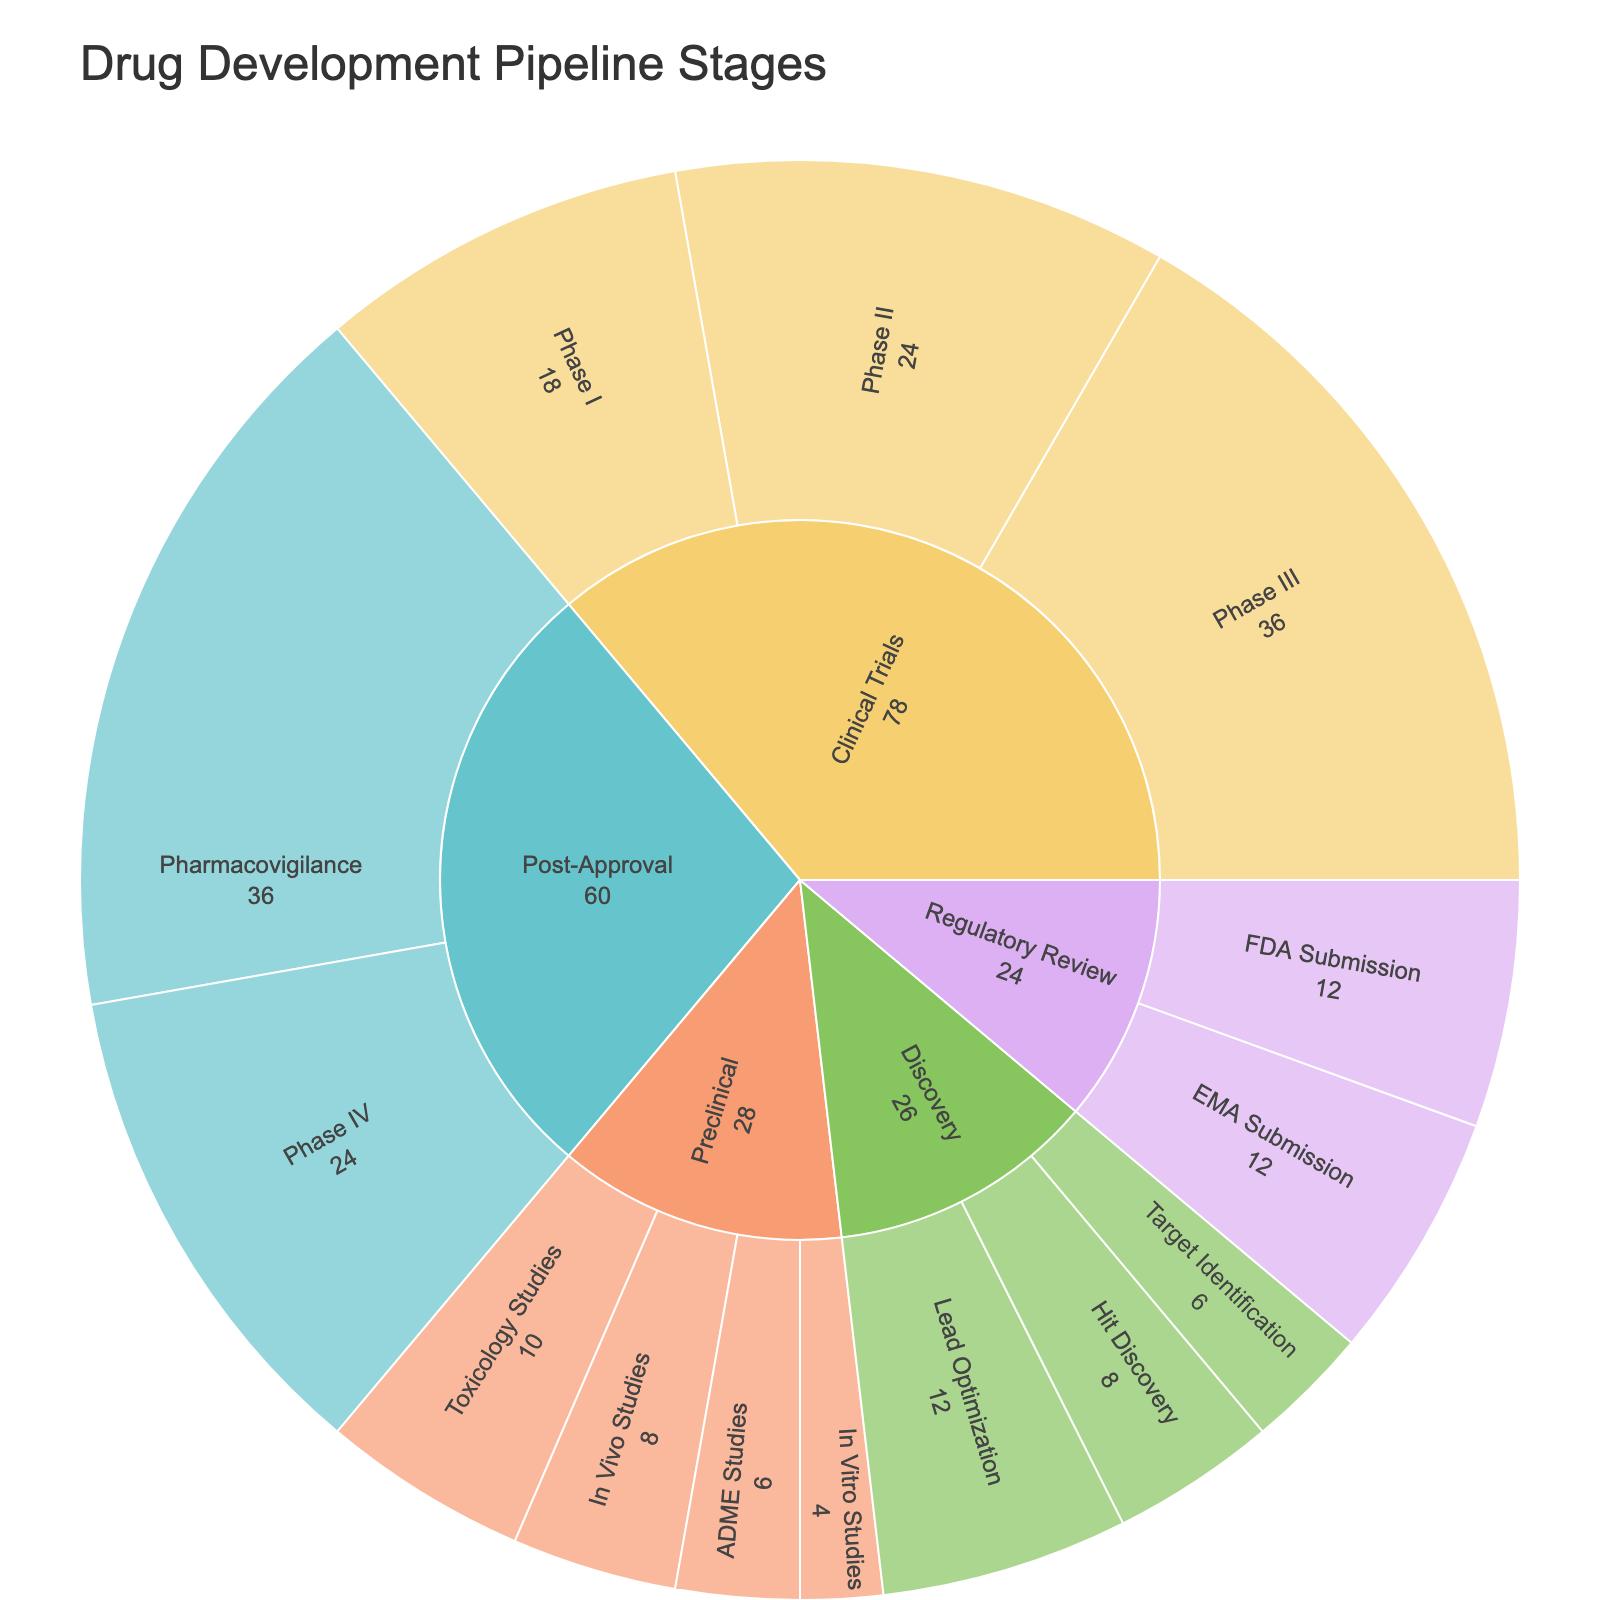What is the title of the Sunburst Plot? The title is typically displayed at the top of the plot and is straightforward to read and interpret.
Answer: Drug Development Pipeline Stages How much total time is spent in the Discovery phase? The Discovery phase includes the subphases Target Identification, Hit Discovery, and Lead Optimization. Summing the time spent in each subphase (6 + 8 + 12) will give the total time.
Answer: 26 months Which phase has the longest single subphase? By examining each subphase across all phases, we find the subphase with the highest time spent. The subphases include (Target Identification: 6, Hit Discovery: 8, Lead Optimization: 12, In Vitro Studies: 4, In Vivo Studies: 8, ADME Studies: 6, Toxicology Studies: 10, Phase I: 18, Phase II: 24, Phase III: 36, FDA Submission: 12, EMA Submission: 12, Phase IV: 24, Pharmacovigilance: 36). The subphase with the highest time is Pharmacovigilance in Post-Approval.
Answer: Post-Approval (Pharmacovigilance) How much longer is the time spent in Clinical Trials compared to Preclinical? We sum the time spent in all subphases of Clinical Trials: (Phase I: 18, Phase II: 24, Phase III: 36) and Preclinical: (In Vitro Studies: 4, In Vivo Studies: 8, ADME Studies: 6, Toxicology Studies: 10) and then find the difference. Clinical Trials: (18 + 24 + 36 = 78), Preclinical: (4 + 8 + 6 + 10 = 28), and the difference is 78 - 28.
Answer: 50 months Which phases share the same total time spent in their respective subphases? By adding the time spent in each phase's subphases, we compare the totals. The two phases where the totals match are Regulatory Review (FDA Submission: 12, EMA Submission: 12 = 24) and Post-Approval (Phase IV: 24, Pharmacovigilance: 36 = 60, adding up to a duration slightly different). Both preclinical (28 months) and Clinical Trials (78 months) differ. Post Examination reveals that Discovery (26 months) is different from others.
Answer: Regulatory Review What is the average time spent in each subphase of the Preclinical stage? Sum the times for all Preclinical subphases and divide by the number of subphases: Total (4 + 8 + 6 + 10 = 28) divided by number of subphases (4).
Answer: 7 months Are there any phases with exactly four subphases? By counting the subphases listed under each main phase in the Sunburst Plot data, we identify that Discovery and Preclinical each have four subphases listed.
Answer: Yes (Discovery and Preclinical) Which phase encompasses the highest total time spent? Calculate and compare the total time spent in each phase: Discovery (26), Preclinical (28), Clinical Trials (78), Regulatory Review (24), Post-Approval (60). Clinical Trials has the highest total time spent.
Answer: Clinical Trials (78 months) What is the smallest time spent in any given subphase? Examine the time spent for each subphase. The smallest time spent is In Vitro Studies with 4 months.
Answer: 4 months How does the time spent in Lead Optimization compare to Phase II of Clinical Trials? By directly comparing the values of the two subphases, Lead Optimization is 12 months, and Phase II is 24 months. The difference is 24 - 12.
Answer: 12 months less than Phase II 